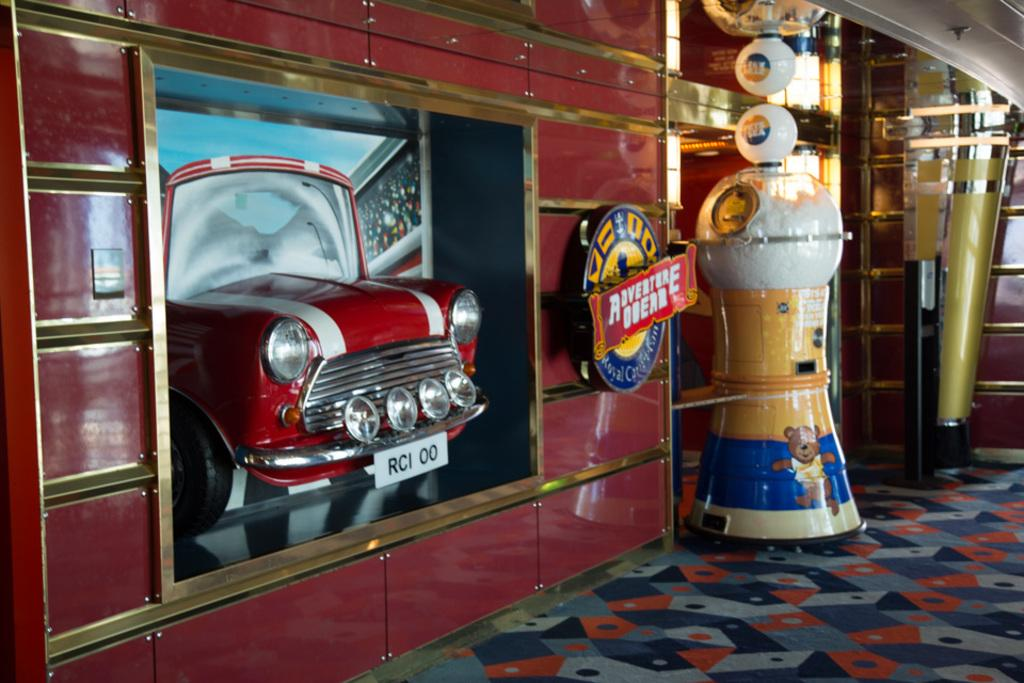What type of vehicle is in the image? There is a red car in the image. Where is the red car located in the image? The red car is on the left side of the image. What other object can be seen in the image? There is a decorative glass object in the image. Where is the decorative glass object located in the image? The decorative glass object is on the floor and on the right side of the image. How many pies are being served on the hood of the red car in the image? There are no pies present in the image; it only features a red car and a decorative glass object. 